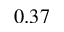<formula> <loc_0><loc_0><loc_500><loc_500>0 . 3 7</formula> 